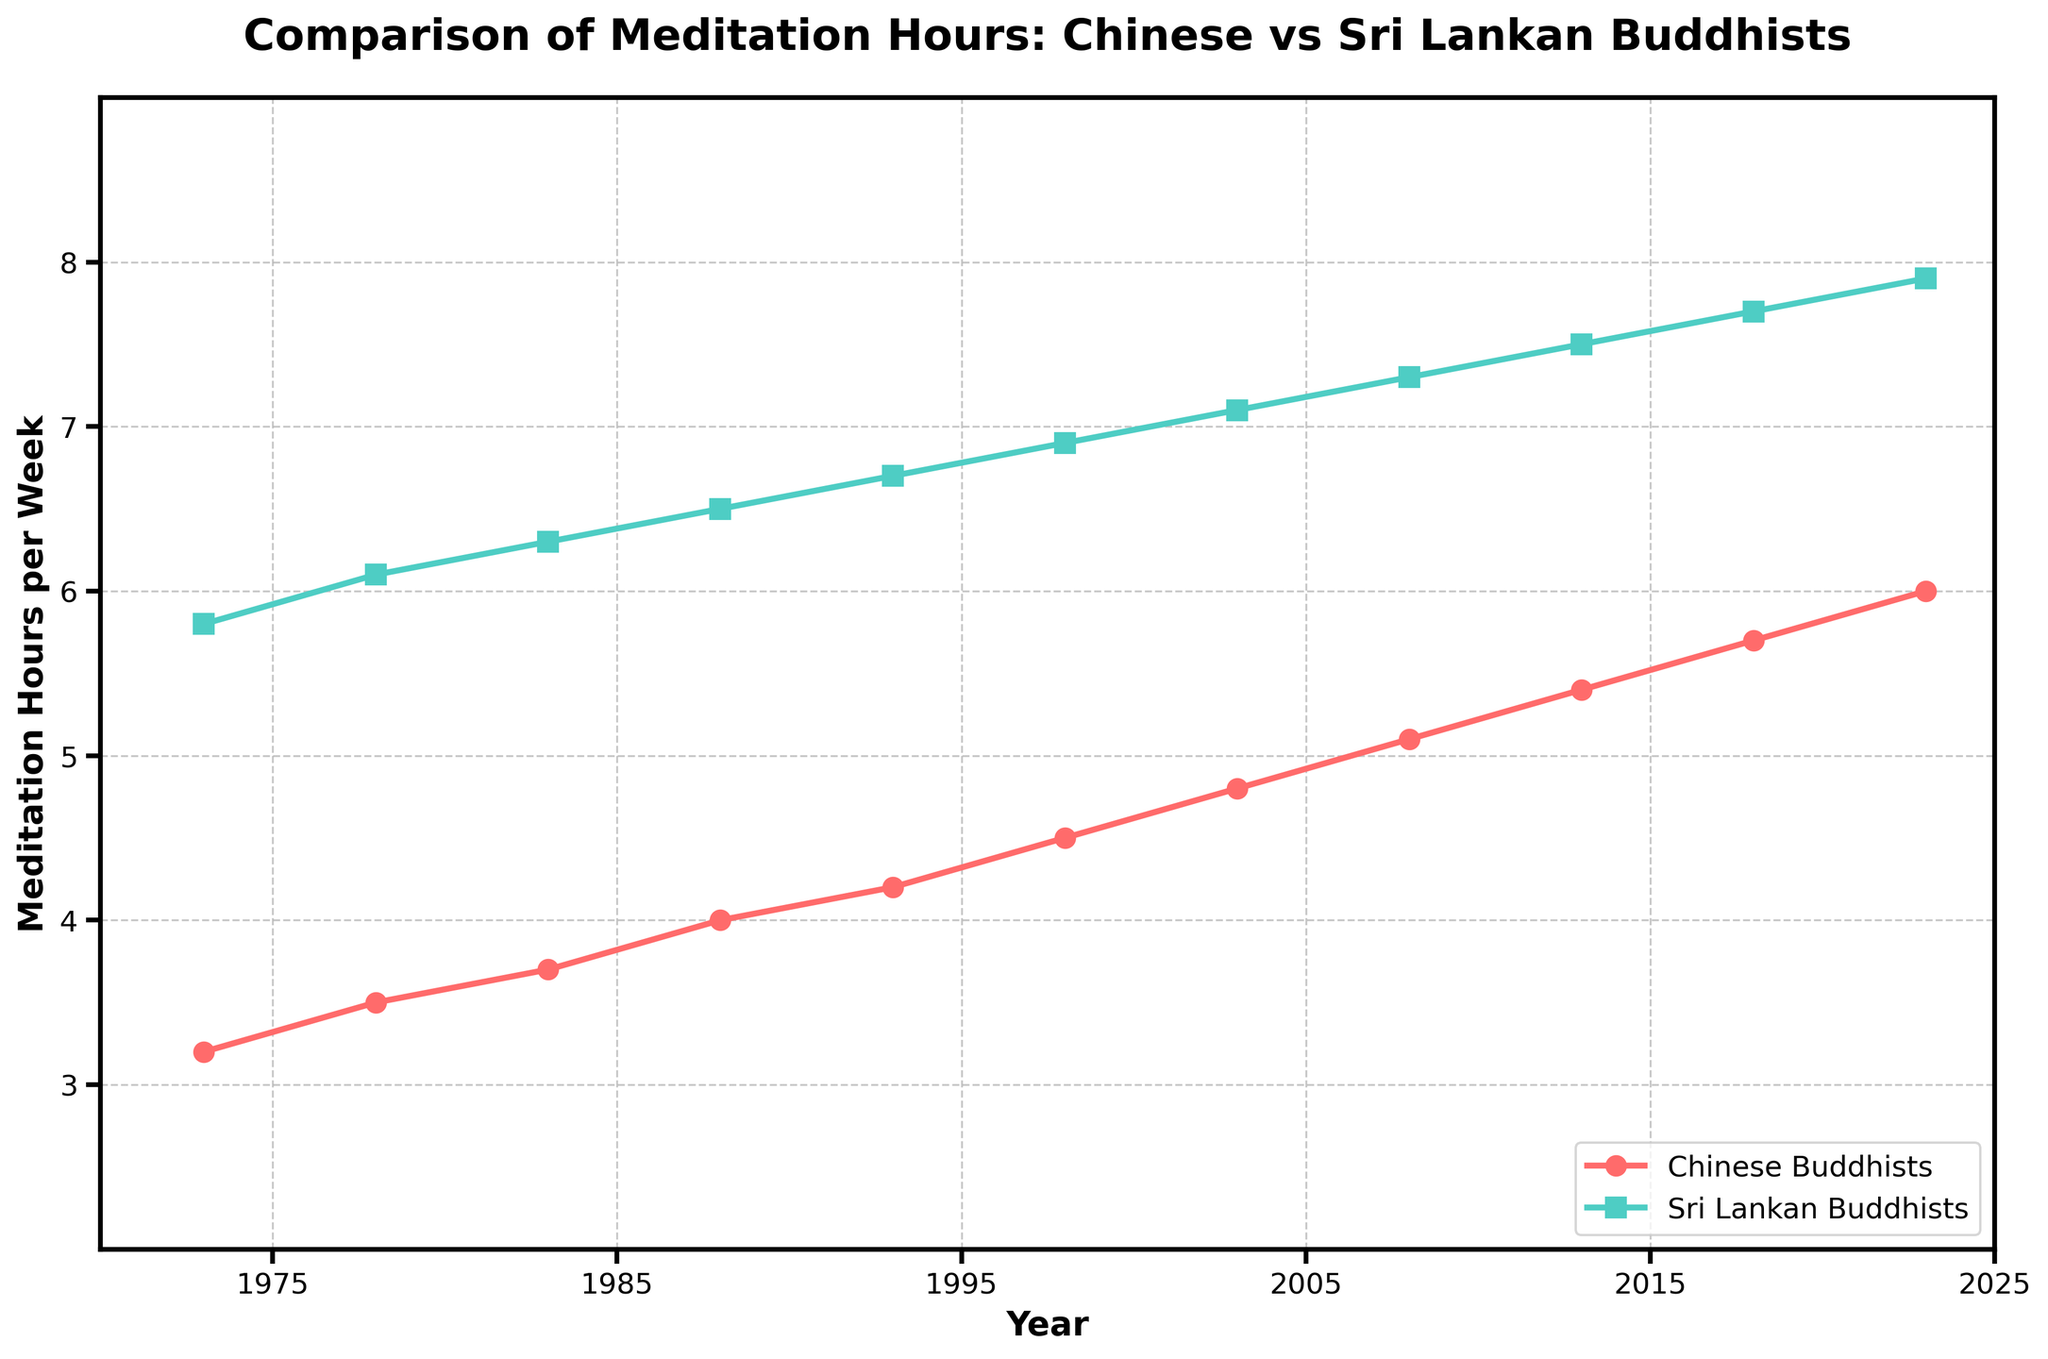What is the difference in meditation hours per week between Chinese and Sri Lankan Buddhists in 2023? Look at the data points for the year 2023. The meditation hours for Chinese Buddhists in 2023 are 6.0, and for Sri Lankan Buddhists, it is 7.9. Calculate the difference: 7.9 - 6.0 = 1.9
Answer: 1.9 How have the meditation hours for Chinese Buddhists changed from 1973 to 2023? Find the data points for Chinese Buddhists in 1973 and 2023. In 1973, it was 3.2 hours/week, and in 2023, it increased to 6.0 hours/week. The change is 6.0 - 3.2 = 2.8
Answer: Increased by 2.8 hours In which year did meditation hours for Chinese Buddhists surpass 5 hours per week for the first time? Trace the data points for Chinese Buddhists and identify when the value first exceeds 5. In 2008, it reached 5.1
Answer: 2008 Which group has consistently higher meditation hours per week over the 50-year period? Compare the two lines representing Chinese and Sri Lankan Buddhists over the entire period. The line representing Sri Lankan Buddhists is always above the one for Chinese Buddhists
Answer: Sri Lankan Buddhists What is the overall trend in meditation hours per week for both groups over the past 50 years? Observe the trajectory of both lines from 1973 to 2023. Both lines show an upward trend indicating an increase in hours over the years
Answer: Increasing Between 1978 and 1988, how much did the meditation hours increase for Sri Lankan Buddhists? Look at the data points for Sri Lankan Buddhists in 1978 and 1988. In 1978, it was 6.1; in 1988, it was 6.5. The increase is 6.5 - 6.1 = 0.4
Answer: 0.4 Which group had a higher increase in meditation hours per week from 1993 to 2003? Calculate the increase for each group between 1993 and 2003: Chinese Buddhists increased from 4.2 to 4.8 (4.8 - 4.2 = 0.6), and Sri Lankan Buddhists from 6.7 to 7.1 (7.1 - 6.7 = 0.4). Compare both increases
Answer: Chinese Buddhists What year shows the smallest gap in meditation hours per week between the two groups? Look at the difference between the two data points for each year. The smallest gap is observed in 1973 (5.8 - 3.2 = 2.6)
Answer: 1973 What are the peak meditation hours per week for both groups in the past 50 years? Trace the highest data points for each group. For Chinese Buddhists, it is 6.0 in 2023; for Sri Lankan Buddhists, it is 7.9 in 2023
Answer: Chinese: 6.0, Sri Lankan: 7.9 